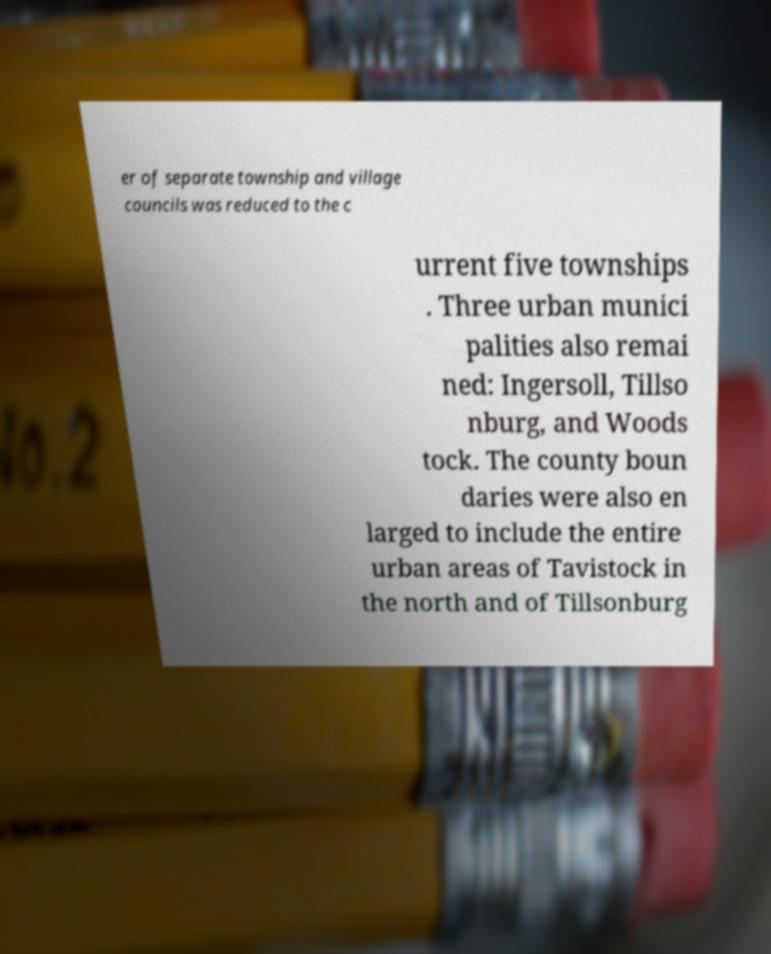For documentation purposes, I need the text within this image transcribed. Could you provide that? er of separate township and village councils was reduced to the c urrent five townships . Three urban munici palities also remai ned: Ingersoll, Tillso nburg, and Woods tock. The county boun daries were also en larged to include the entire urban areas of Tavistock in the north and of Tillsonburg 